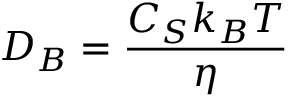Convert formula to latex. <formula><loc_0><loc_0><loc_500><loc_500>D _ { B } = \frac { C _ { S } k _ { B } T } { \eta }</formula> 